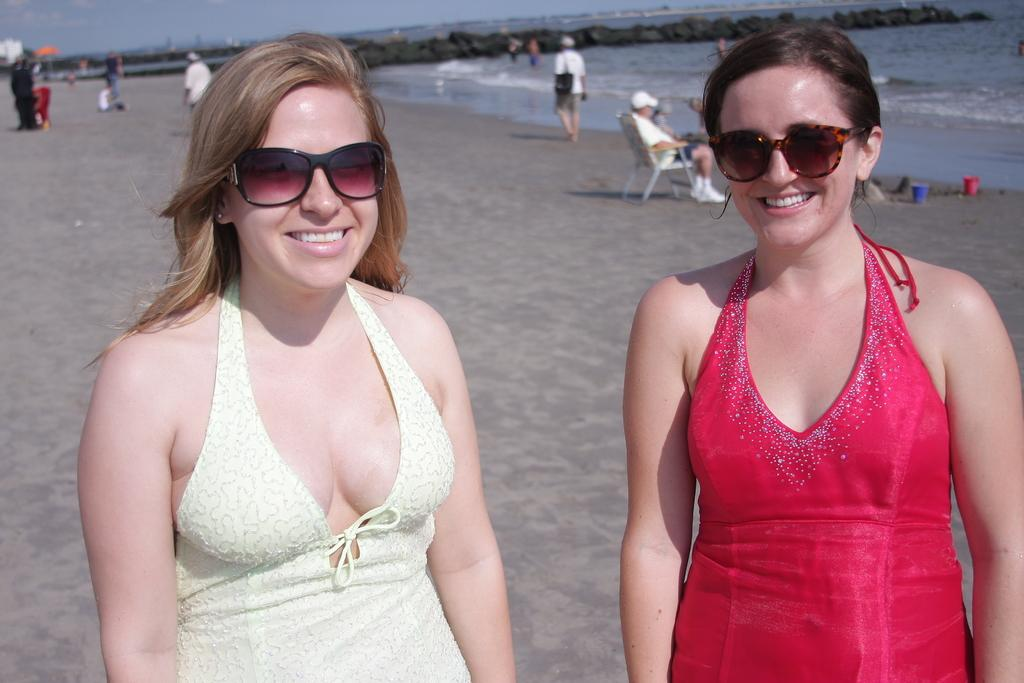Who are the main subjects in the foreground of the image? There are two ladies in the foreground of the image. What can be seen in the background of the image? There are people, water, and stones visible in the background of the image. What is the terrain like at the bottom of the image? There is sand at the bottom of the image. What type of oil can be seen dripping from the ladies' hair in the image? There is no oil visible in the image, nor is it mentioned in the provided facts. 